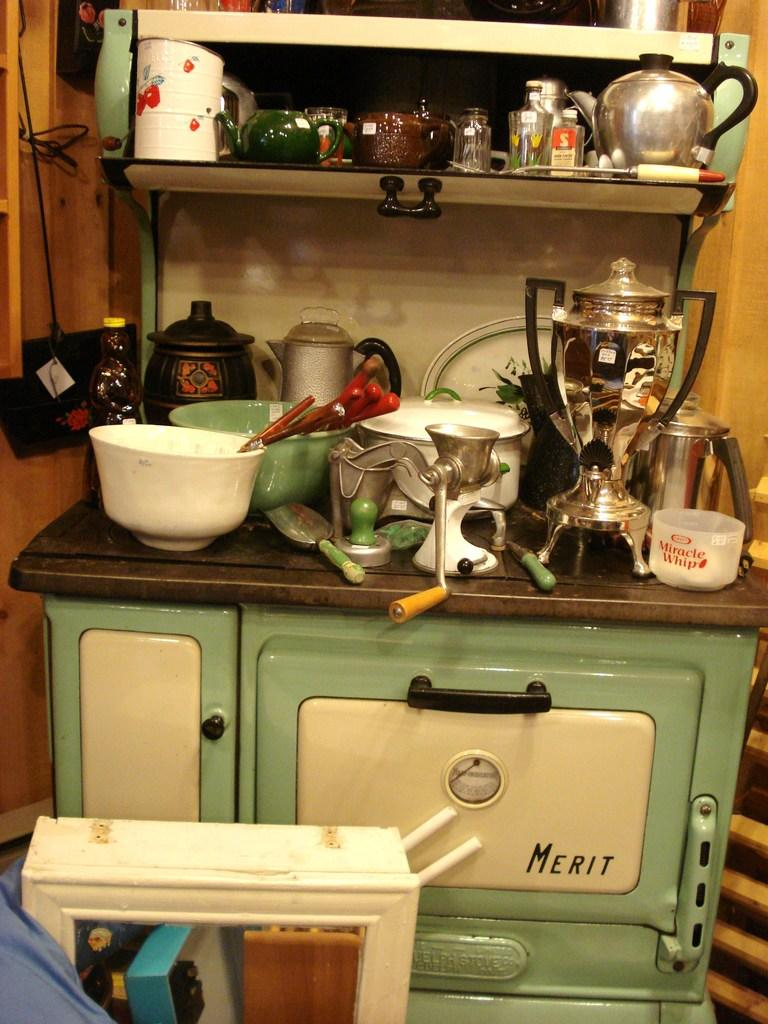Provide a one-sentence caption for the provided image. a clutterred old fashioned teal and white merit stove. 